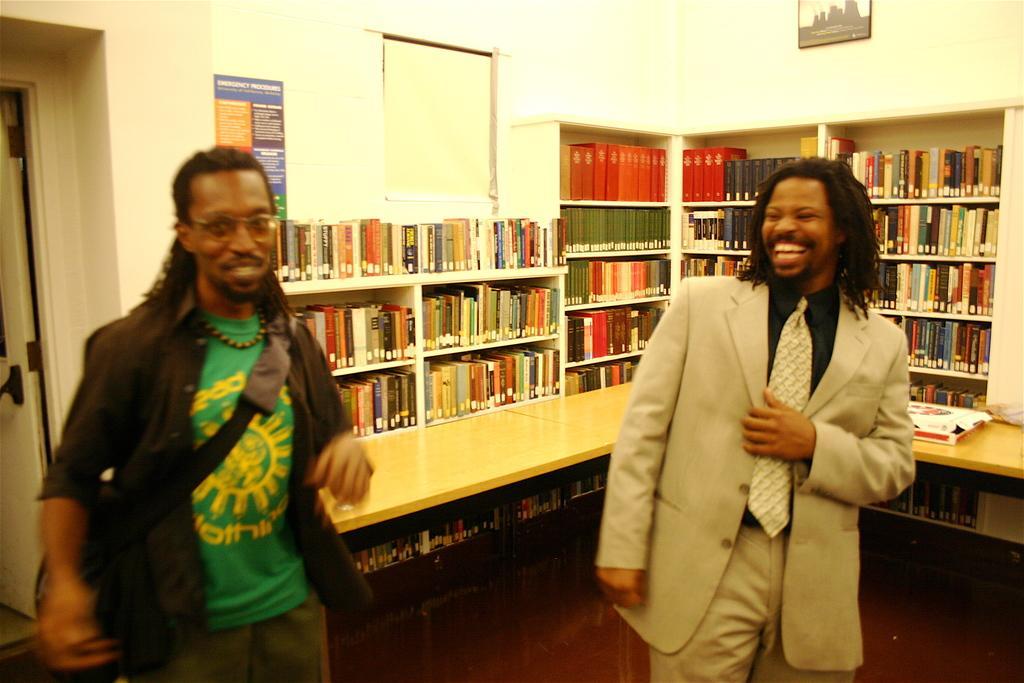Describe this image in one or two sentences. In this picture we can see two people, they are smiling and in the background we can see a wooden platform, shelves, books, wall, photo frame, poster and some objects. 